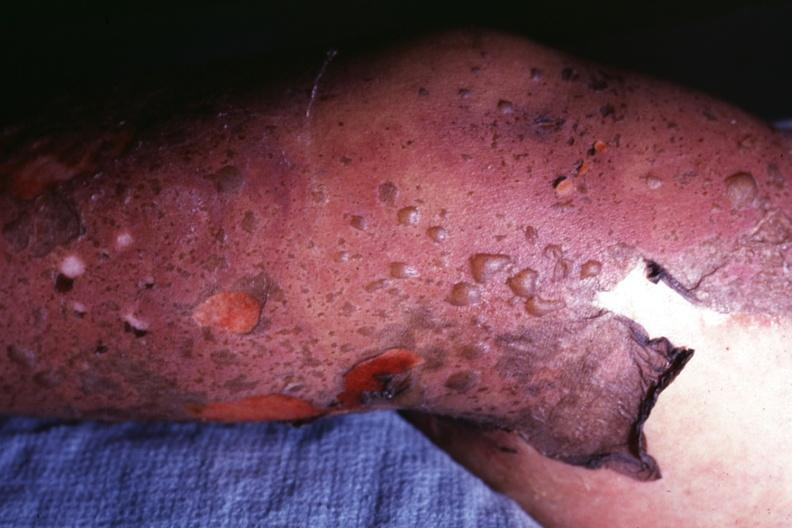what does this image show?
Answer the question using a single word or phrase. Close-up of bullous skin lesions and peeling of skin 